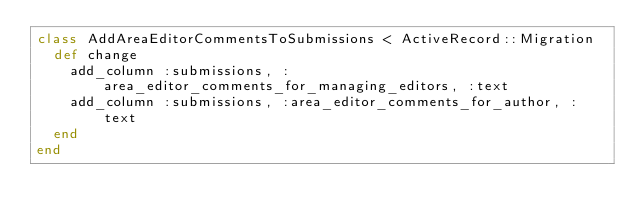<code> <loc_0><loc_0><loc_500><loc_500><_Ruby_>class AddAreaEditorCommentsToSubmissions < ActiveRecord::Migration
  def change
    add_column :submissions, :area_editor_comments_for_managing_editors, :text
    add_column :submissions, :area_editor_comments_for_author, :text
  end
end
</code> 